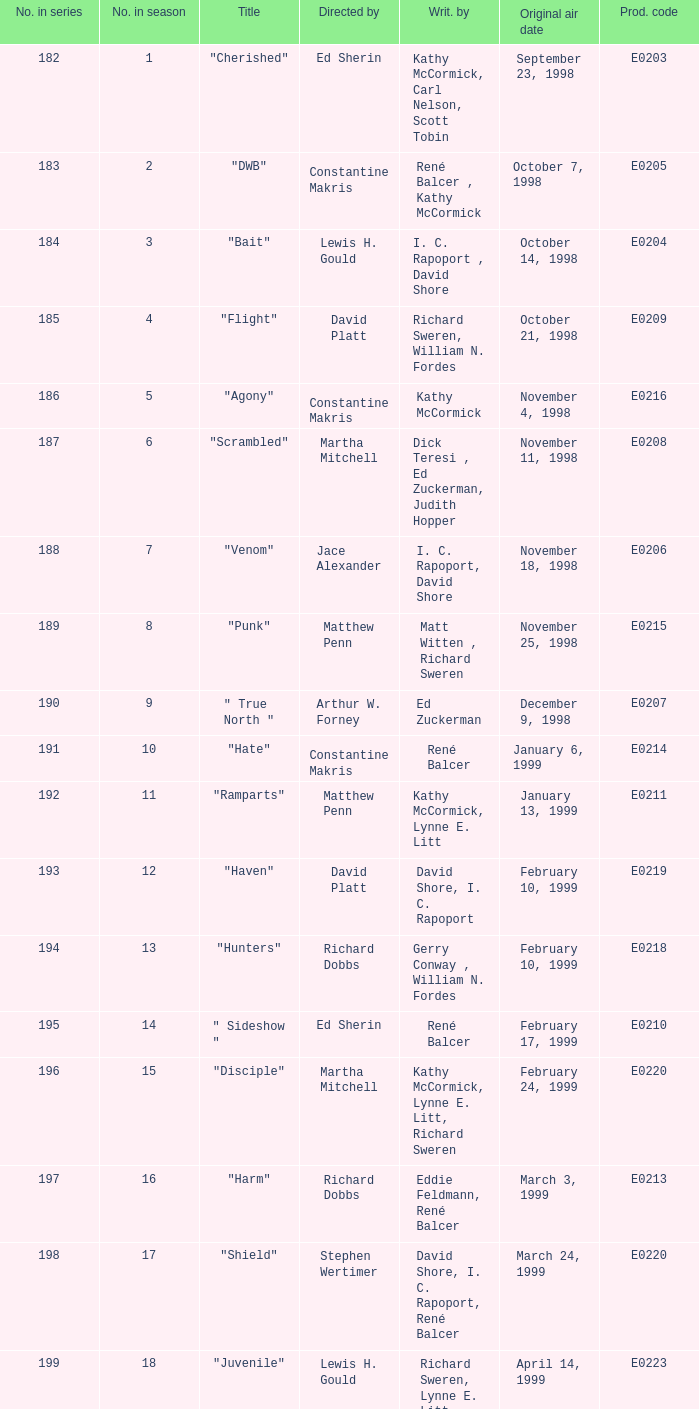What is the season number of the episode written by Matt Witten , Richard Sweren? 8.0. Give me the full table as a dictionary. {'header': ['No. in series', 'No. in season', 'Title', 'Directed by', 'Writ. by', 'Original air date', 'Prod. code'], 'rows': [['182', '1', '"Cherished"', 'Ed Sherin', 'Kathy McCormick, Carl Nelson, Scott Tobin', 'September 23, 1998', 'E0203'], ['183', '2', '"DWB"', 'Constantine Makris', 'René Balcer , Kathy McCormick', 'October 7, 1998', 'E0205'], ['184', '3', '"Bait"', 'Lewis H. Gould', 'I. C. Rapoport , David Shore', 'October 14, 1998', 'E0204'], ['185', '4', '"Flight"', 'David Platt', 'Richard Sweren, William N. Fordes', 'October 21, 1998', 'E0209'], ['186', '5', '"Agony"', 'Constantine Makris', 'Kathy McCormick', 'November 4, 1998', 'E0216'], ['187', '6', '"Scrambled"', 'Martha Mitchell', 'Dick Teresi , Ed Zuckerman, Judith Hopper', 'November 11, 1998', 'E0208'], ['188', '7', '"Venom"', 'Jace Alexander', 'I. C. Rapoport, David Shore', 'November 18, 1998', 'E0206'], ['189', '8', '"Punk"', 'Matthew Penn', 'Matt Witten , Richard Sweren', 'November 25, 1998', 'E0215'], ['190', '9', '" True North "', 'Arthur W. Forney', 'Ed Zuckerman', 'December 9, 1998', 'E0207'], ['191', '10', '"Hate"', 'Constantine Makris', 'René Balcer', 'January 6, 1999', 'E0214'], ['192', '11', '"Ramparts"', 'Matthew Penn', 'Kathy McCormick, Lynne E. Litt', 'January 13, 1999', 'E0211'], ['193', '12', '"Haven"', 'David Platt', 'David Shore, I. C. Rapoport', 'February 10, 1999', 'E0219'], ['194', '13', '"Hunters"', 'Richard Dobbs', 'Gerry Conway , William N. Fordes', 'February 10, 1999', 'E0218'], ['195', '14', '" Sideshow "', 'Ed Sherin', 'René Balcer', 'February 17, 1999', 'E0210'], ['196', '15', '"Disciple"', 'Martha Mitchell', 'Kathy McCormick, Lynne E. Litt, Richard Sweren', 'February 24, 1999', 'E0220'], ['197', '16', '"Harm"', 'Richard Dobbs', 'Eddie Feldmann, René Balcer', 'March 3, 1999', 'E0213'], ['198', '17', '"Shield"', 'Stephen Wertimer', 'David Shore, I. C. Rapoport, René Balcer', 'March 24, 1999', 'E0220'], ['199', '18', '"Juvenile"', 'Lewis H. Gould', 'Richard Sweren, Lynne E. Litt', 'April 14, 1999', 'E0223'], ['200', '19', '"Tabula Rasa"', 'Richard Dobbs', 'William N. Fordes, Kathy McCormick', 'April 21, 1999', 'E0222'], ['201', '20', '" Empire "', 'Matthew Penn', 'René Balcer', 'May 5, 1999', 'E0217'], ['202', '21', '"Ambitious"', 'Christopher Misiano', 'Barry M. Schkolnick, Richard Sweren', 'May 12, 1999', 'E0221'], ['203', '22', '"Admissions"', 'Jace Alexander', 'William N. Fordes, Lynne E. Litt, Kathy McCormick', 'May 19, 1999', 'E0224'], ['204', '23', '"Refuge (Part 1)"', 'Constantine Makris', 'René Balcer', 'May 26, 1999', 'E0212']]} 